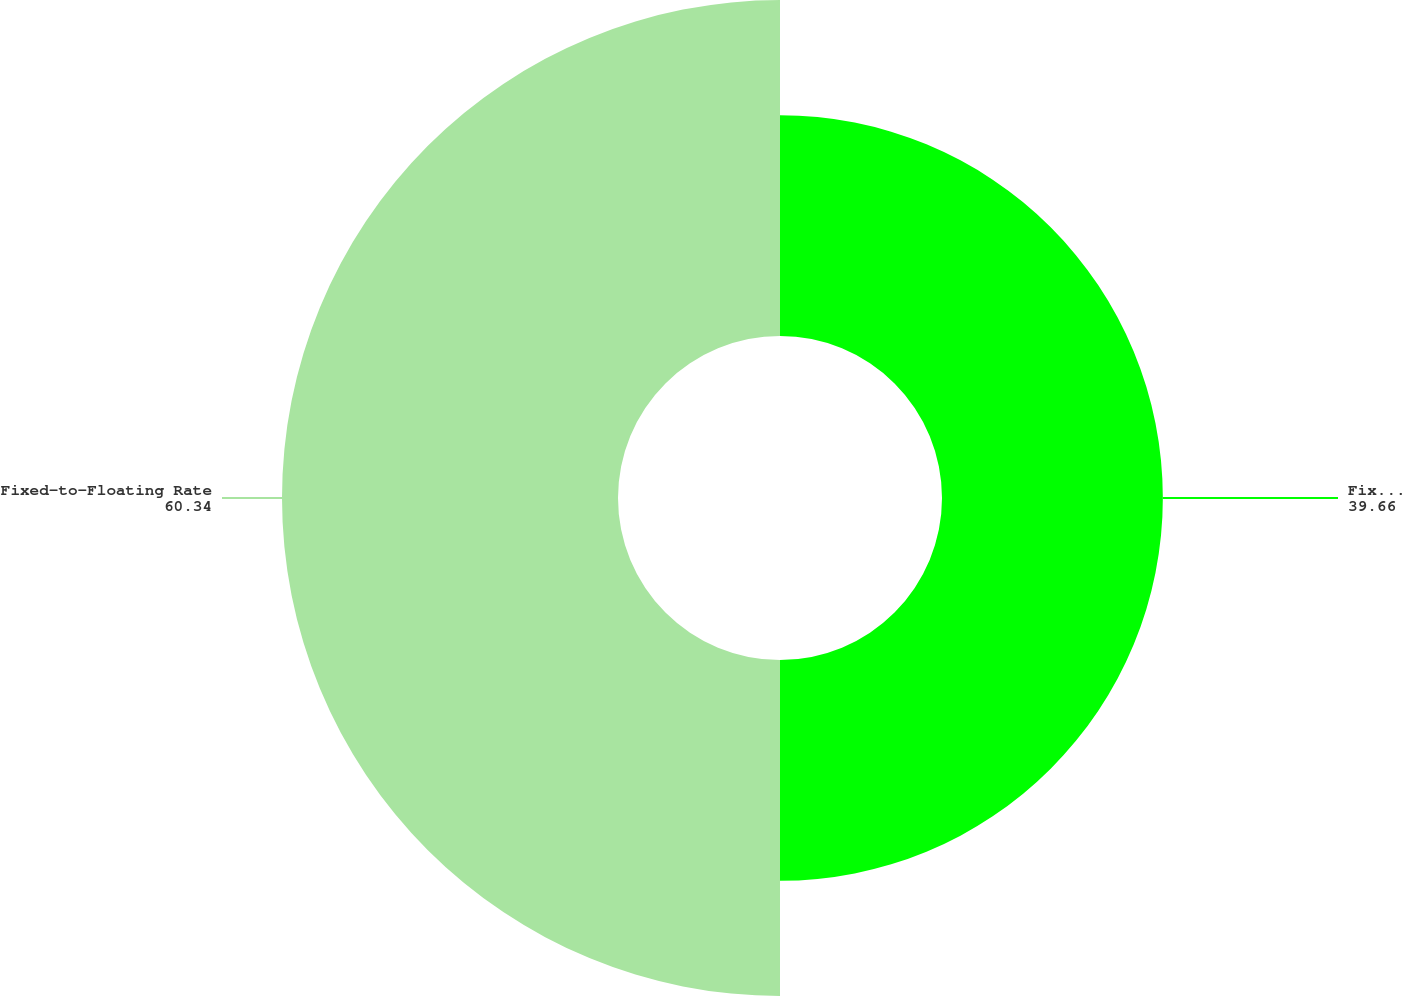Convert chart to OTSL. <chart><loc_0><loc_0><loc_500><loc_500><pie_chart><fcel>Fixed Rate Cumulative<fcel>Fixed-to-Floating Rate<nl><fcel>39.66%<fcel>60.34%<nl></chart> 